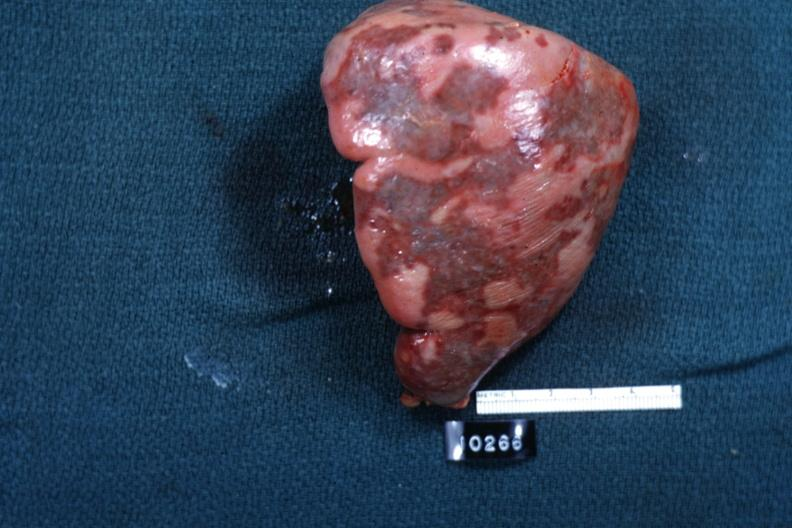s intraductal lesions cut surface is slide?
Answer the question using a single word or phrase. No 